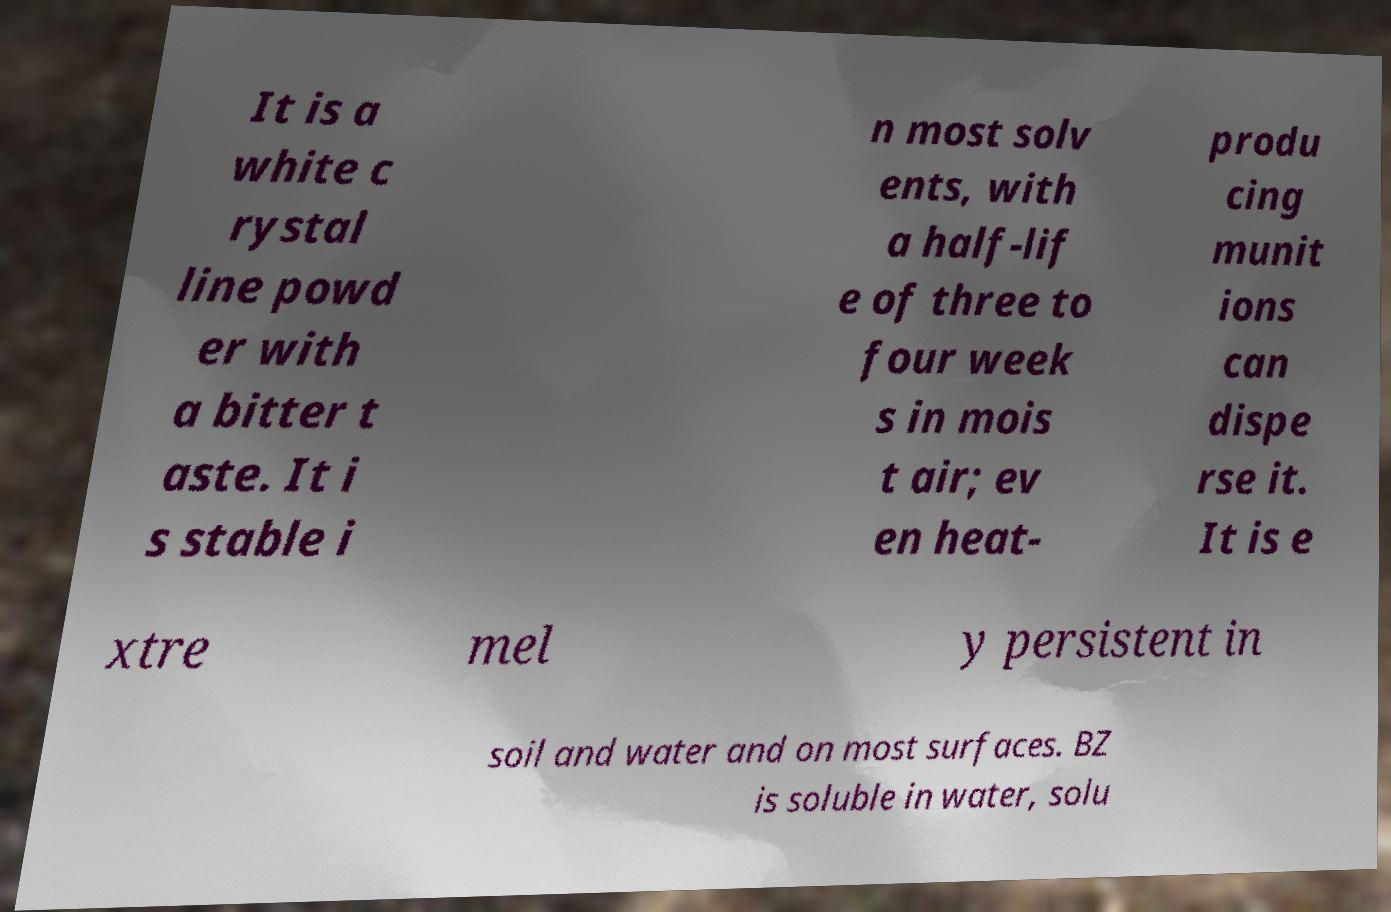Could you extract and type out the text from this image? It is a white c rystal line powd er with a bitter t aste. It i s stable i n most solv ents, with a half-lif e of three to four week s in mois t air; ev en heat- produ cing munit ions can dispe rse it. It is e xtre mel y persistent in soil and water and on most surfaces. BZ is soluble in water, solu 